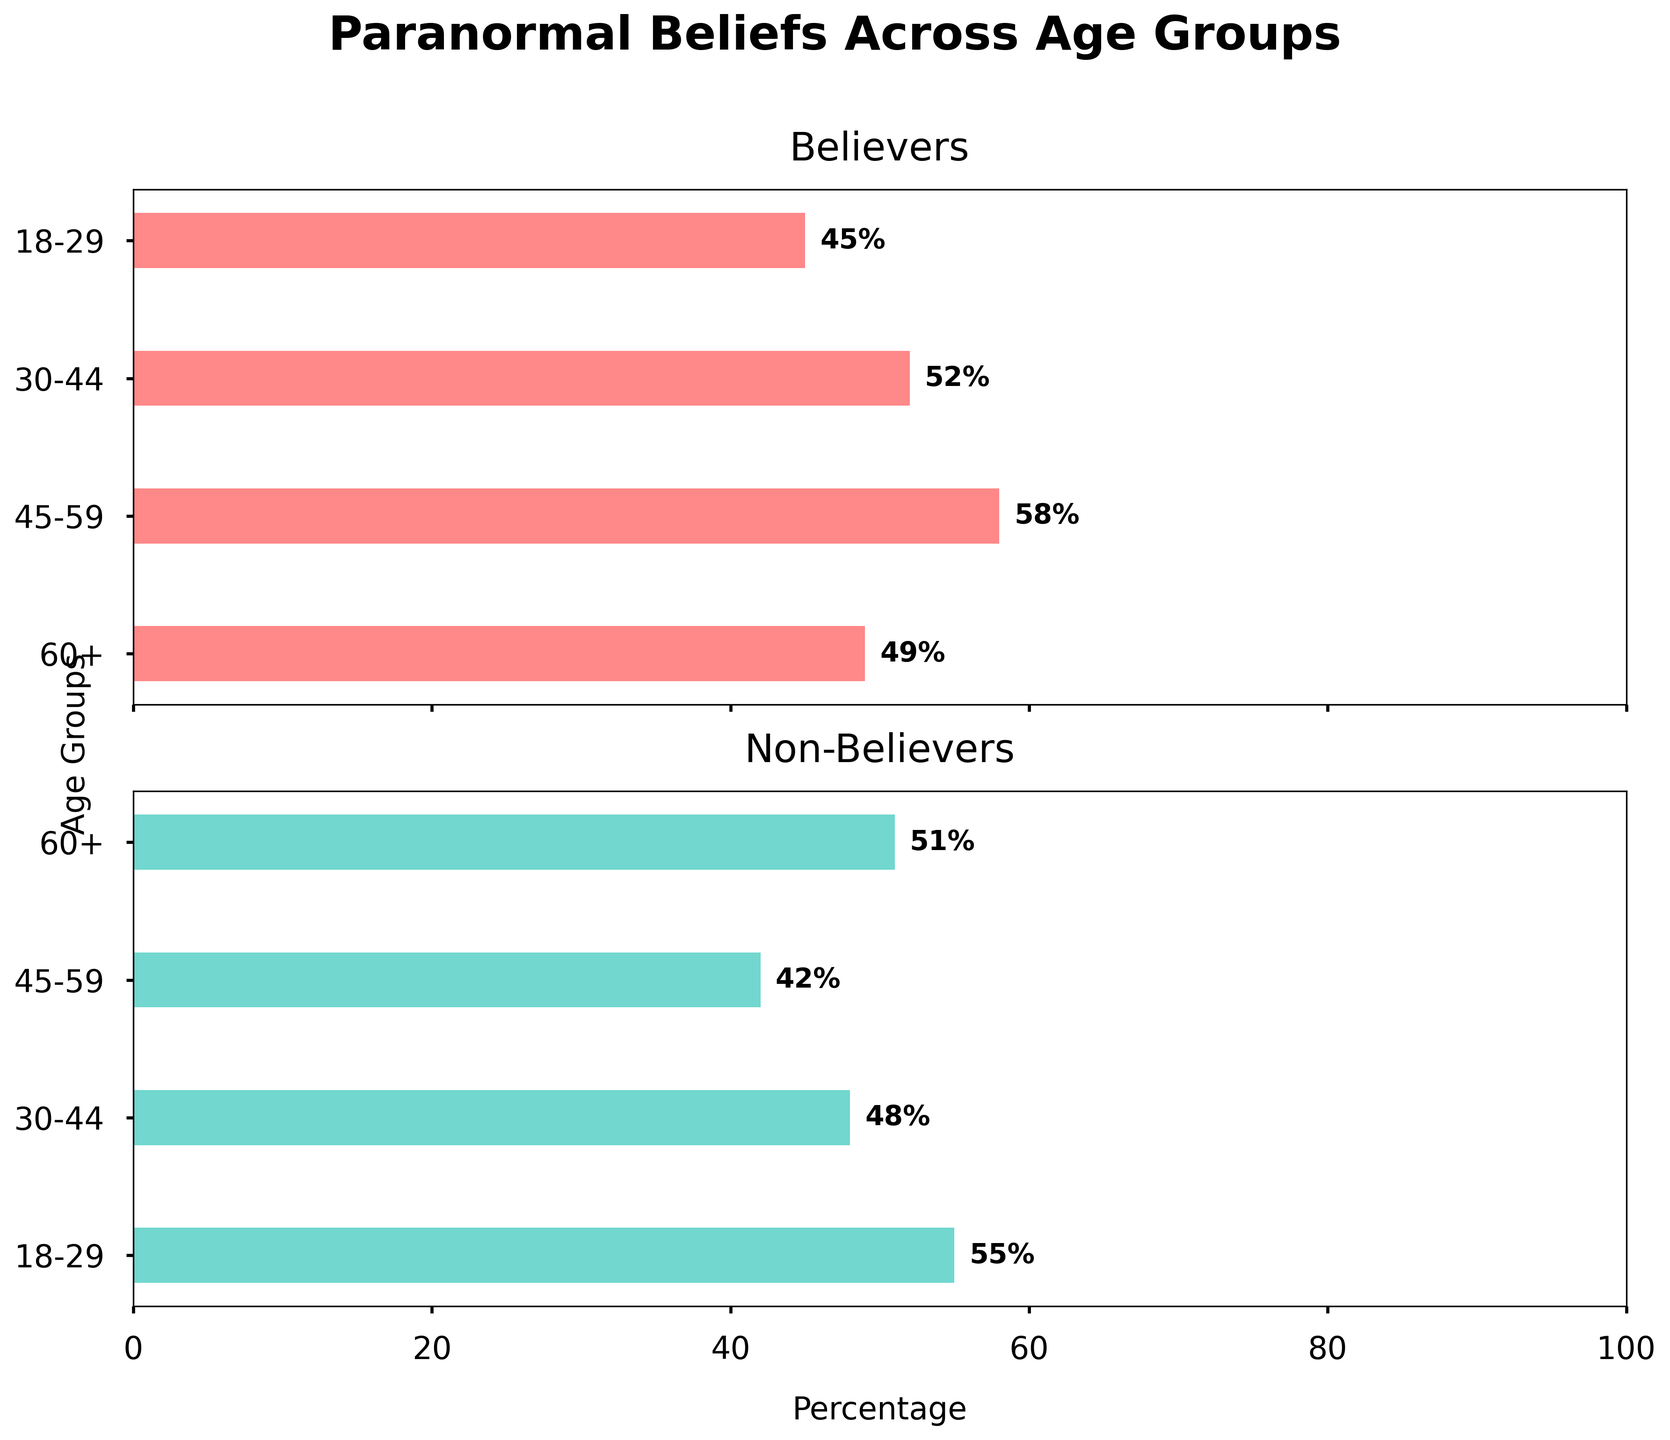What is the title of the figure? The title of the figure is located at the top of the plot and gives an overview of what the figure represents.
Answer: Paranormal Beliefs Across Age Groups Which age group has the highest percentage of believers in paranormal phenomena? Look at the "Believers" subplot and find the age group with the highest percentage bar. The 45-59 age group has the highest bar at 58%.
Answer: 45-59 How does the percentage of believers and non-believers in the 60+ age group compare? Compare the lengths of the bars in the horizontal subplots for the 60+ age group. Believers percentage is 49% and non-believers percentage is 51%.
Answer: Believers: 49%, Non-believers: 51% What is the average percentage of believers across all age groups? Sum the believers' percentages across all age groups and divide by the number of age groups: (45 + 52 + 58 + 49) / 4 = 204 / 4.
Answer: 51% Which age group has the closest percentage between believers and non-believers? Check the lengths of the bars in both subplots and find the age group where the percentages are the closest. The 60+ age group has percentages of 49% believers and 51% non-believers.
Answer: 60+ Is there any age group where believers' percentage is less than non-believers' percentage? If so, which one? Compare the believers and non-believers percentages in each age group. The 18-29 age group has 45% believers and 55% non-believers.
Answer: 18-29 What is the difference in percentage between believers and non-believers aged 30-44? Subtract the non-believers percentage from the believers percentage for the 30-44 age group: 52% - 48% = 4%.
Answer: 4% Is the percentage of believers higher than non-believers in the 45-59 age group? Compare the believers percentage (58%) with the non-believers percentage (42%) in the 45-59 age group.
Answer: Yes Which two age groups have the exact same percentage combination when comparing believers to non-believers? Look for age groups with the same percentage values in the plot. None of the age groups have the exact same combination of believers and non-believers percentages.
Answer: None 